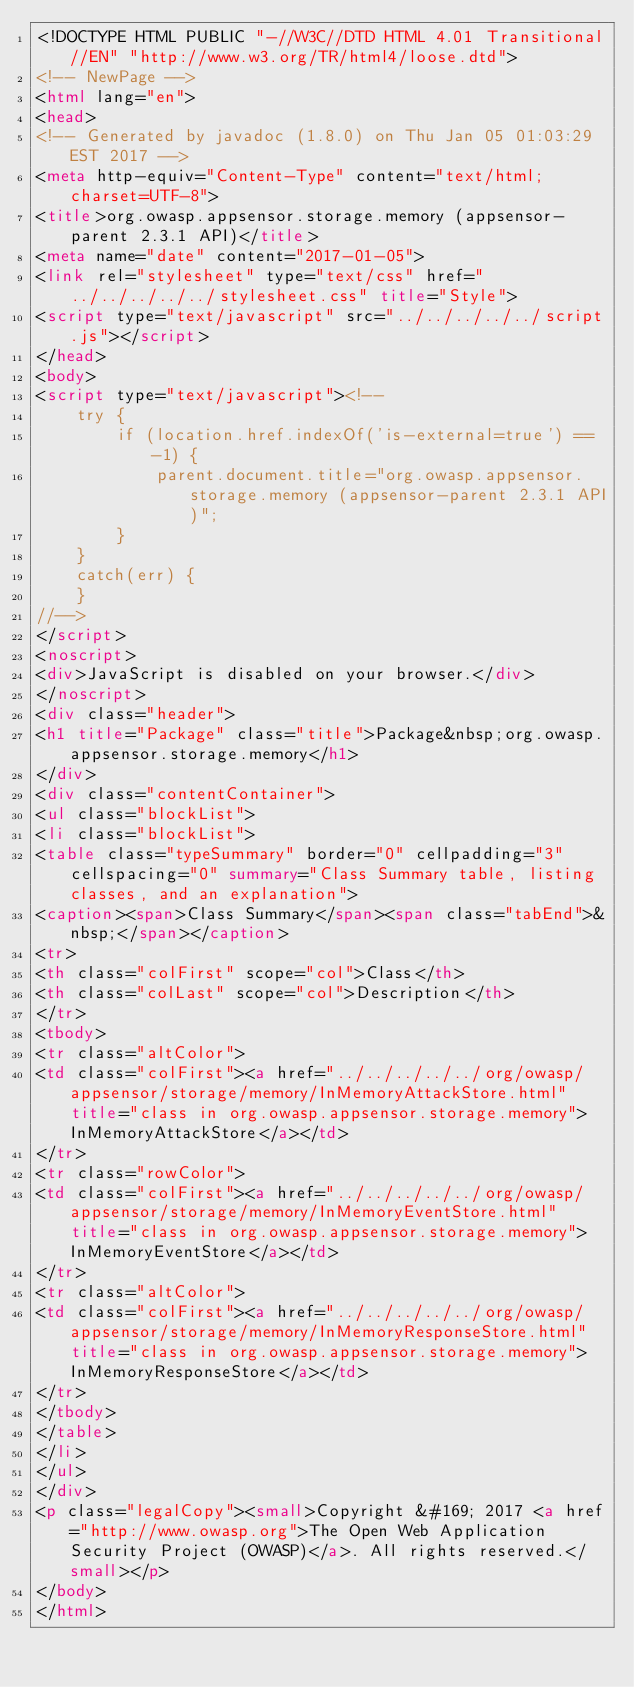Convert code to text. <code><loc_0><loc_0><loc_500><loc_500><_HTML_><!DOCTYPE HTML PUBLIC "-//W3C//DTD HTML 4.01 Transitional//EN" "http://www.w3.org/TR/html4/loose.dtd">
<!-- NewPage -->
<html lang="en">
<head>
<!-- Generated by javadoc (1.8.0) on Thu Jan 05 01:03:29 EST 2017 -->
<meta http-equiv="Content-Type" content="text/html; charset=UTF-8">
<title>org.owasp.appsensor.storage.memory (appsensor-parent 2.3.1 API)</title>
<meta name="date" content="2017-01-05">
<link rel="stylesheet" type="text/css" href="../../../../../stylesheet.css" title="Style">
<script type="text/javascript" src="../../../../../script.js"></script>
</head>
<body>
<script type="text/javascript"><!--
    try {
        if (location.href.indexOf('is-external=true') == -1) {
            parent.document.title="org.owasp.appsensor.storage.memory (appsensor-parent 2.3.1 API)";
        }
    }
    catch(err) {
    }
//-->
</script>
<noscript>
<div>JavaScript is disabled on your browser.</div>
</noscript>
<div class="header">
<h1 title="Package" class="title">Package&nbsp;org.owasp.appsensor.storage.memory</h1>
</div>
<div class="contentContainer">
<ul class="blockList">
<li class="blockList">
<table class="typeSummary" border="0" cellpadding="3" cellspacing="0" summary="Class Summary table, listing classes, and an explanation">
<caption><span>Class Summary</span><span class="tabEnd">&nbsp;</span></caption>
<tr>
<th class="colFirst" scope="col">Class</th>
<th class="colLast" scope="col">Description</th>
</tr>
<tbody>
<tr class="altColor">
<td class="colFirst"><a href="../../../../../org/owasp/appsensor/storage/memory/InMemoryAttackStore.html" title="class in org.owasp.appsensor.storage.memory">InMemoryAttackStore</a></td>
</tr>
<tr class="rowColor">
<td class="colFirst"><a href="../../../../../org/owasp/appsensor/storage/memory/InMemoryEventStore.html" title="class in org.owasp.appsensor.storage.memory">InMemoryEventStore</a></td>
</tr>
<tr class="altColor">
<td class="colFirst"><a href="../../../../../org/owasp/appsensor/storage/memory/InMemoryResponseStore.html" title="class in org.owasp.appsensor.storage.memory">InMemoryResponseStore</a></td>
</tr>
</tbody>
</table>
</li>
</ul>
</div>
<p class="legalCopy"><small>Copyright &#169; 2017 <a href="http://www.owasp.org">The Open Web Application Security Project (OWASP)</a>. All rights reserved.</small></p>
</body>
</html>
</code> 